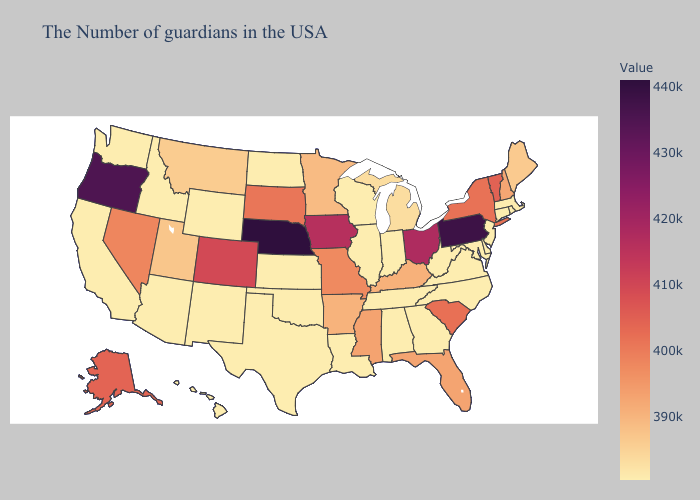Among the states that border Connecticut , does Massachusetts have the highest value?
Write a very short answer. No. Does Pennsylvania have the lowest value in the Northeast?
Answer briefly. No. Among the states that border Delaware , which have the lowest value?
Keep it brief. New Jersey, Maryland. Does South Carolina have the highest value in the South?
Quick response, please. Yes. Which states hav the highest value in the West?
Short answer required. Oregon. Does Kansas have the lowest value in the MidWest?
Give a very brief answer. Yes. Which states have the lowest value in the USA?
Short answer required. Rhode Island, Connecticut, New Jersey, Delaware, Maryland, Virginia, North Carolina, West Virginia, Georgia, Indiana, Alabama, Tennessee, Wisconsin, Illinois, Louisiana, Kansas, Oklahoma, Texas, North Dakota, Wyoming, New Mexico, Arizona, Idaho, California, Washington, Hawaii. Is the legend a continuous bar?
Give a very brief answer. Yes. Among the states that border Texas , does Oklahoma have the lowest value?
Write a very short answer. Yes. Does Nebraska have the highest value in the USA?
Keep it brief. Yes. 